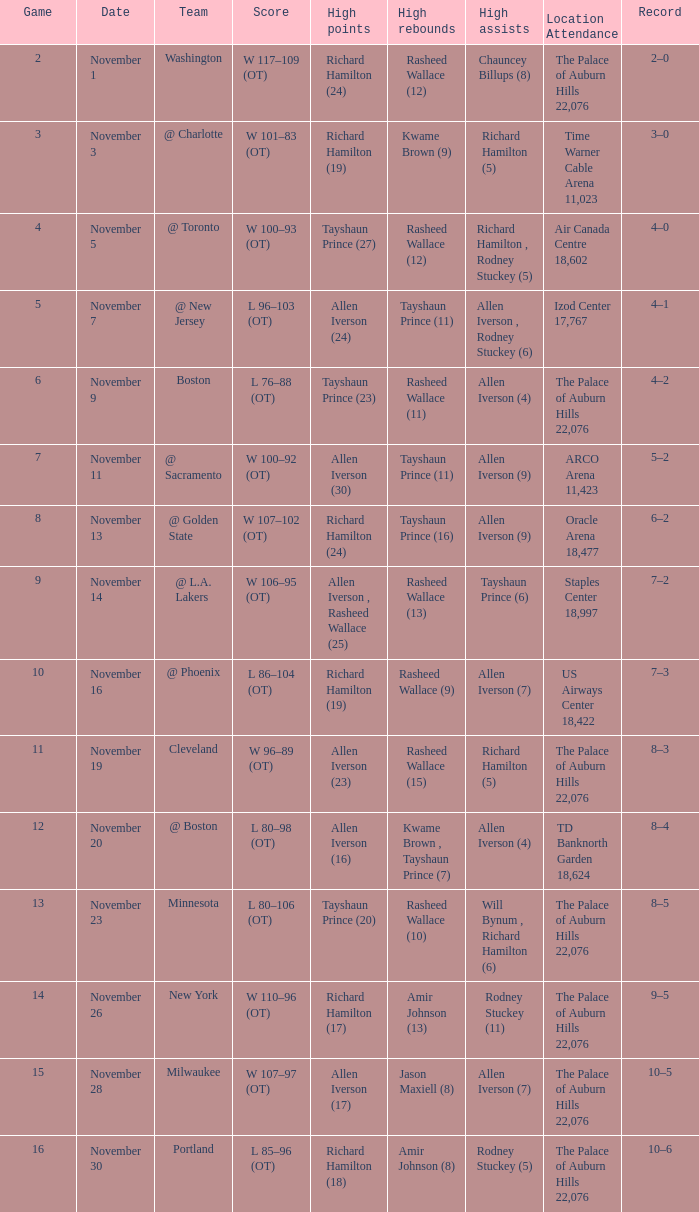When the team is "milwaukee," what is the average game like? 15.0. 